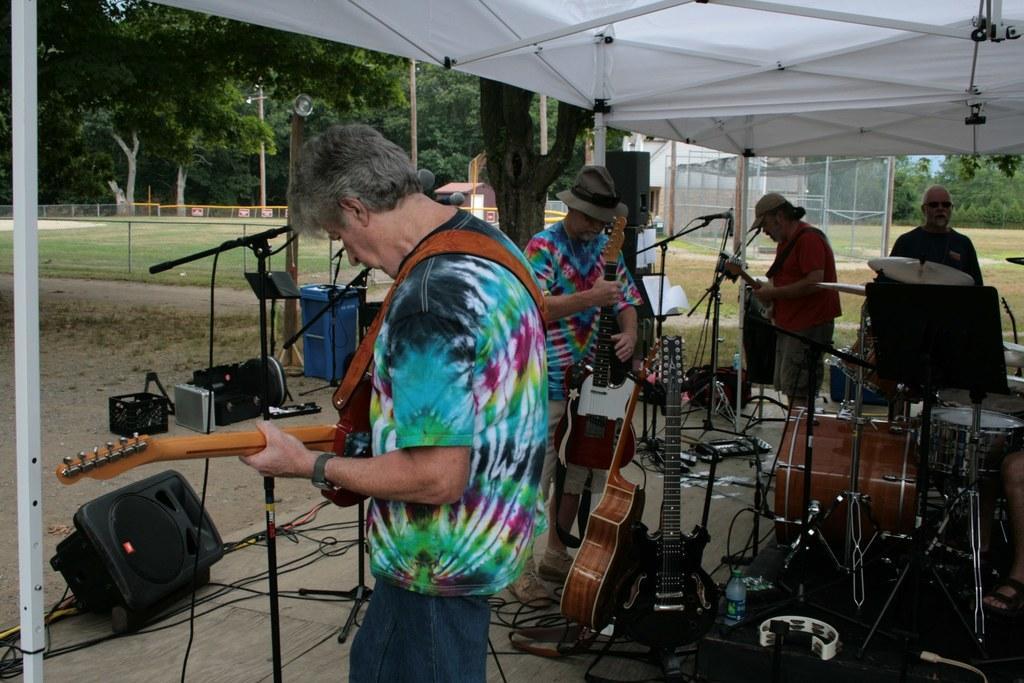How would you summarize this image in a sentence or two? In the center of the image we can see a few people are standing and they are holding guitars. And they are under a tent. And we can see speakers, microphones and some musical instruments around them. In the background we can see trees, grass, poles, fence etc. 